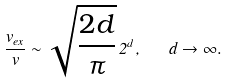<formula> <loc_0><loc_0><loc_500><loc_500>\frac { v _ { e x } } { v } \sim \sqrt { \frac { 2 d } { \pi } } \, 2 ^ { d } , \quad d \rightarrow \infty .</formula> 